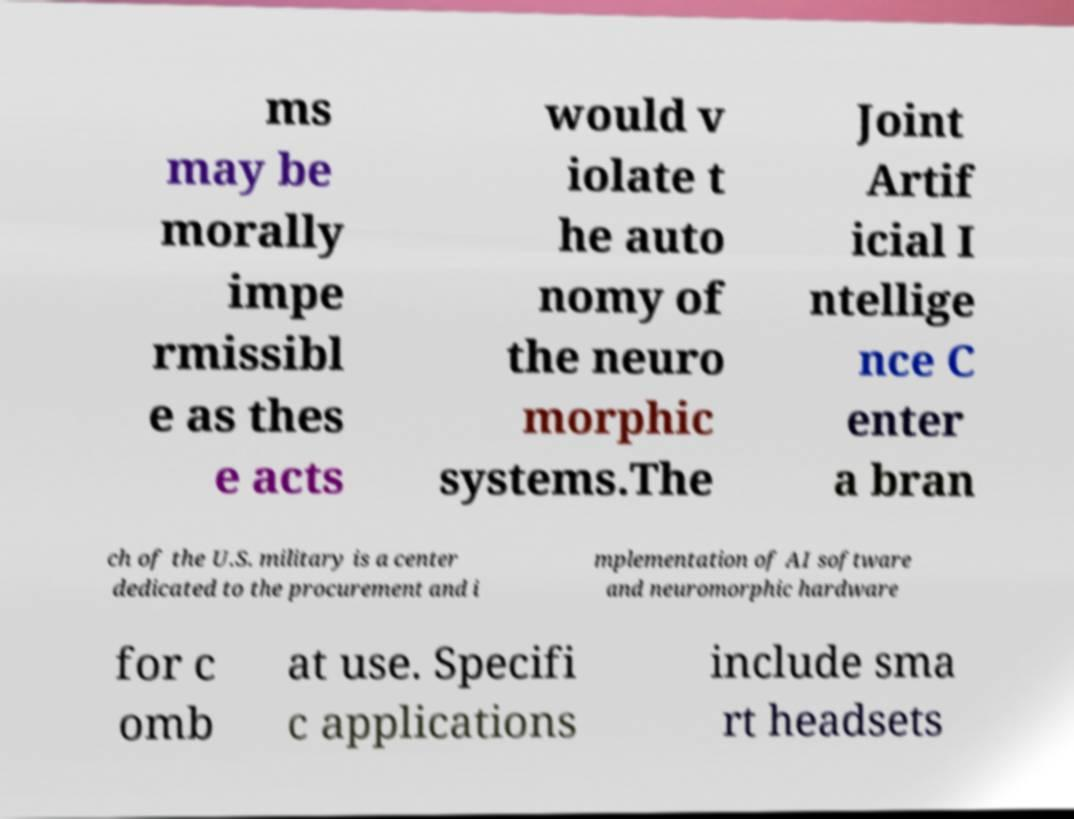Please identify and transcribe the text found in this image. ms may be morally impe rmissibl e as thes e acts would v iolate t he auto nomy of the neuro morphic systems.The Joint Artif icial I ntellige nce C enter a bran ch of the U.S. military is a center dedicated to the procurement and i mplementation of AI software and neuromorphic hardware for c omb at use. Specifi c applications include sma rt headsets 